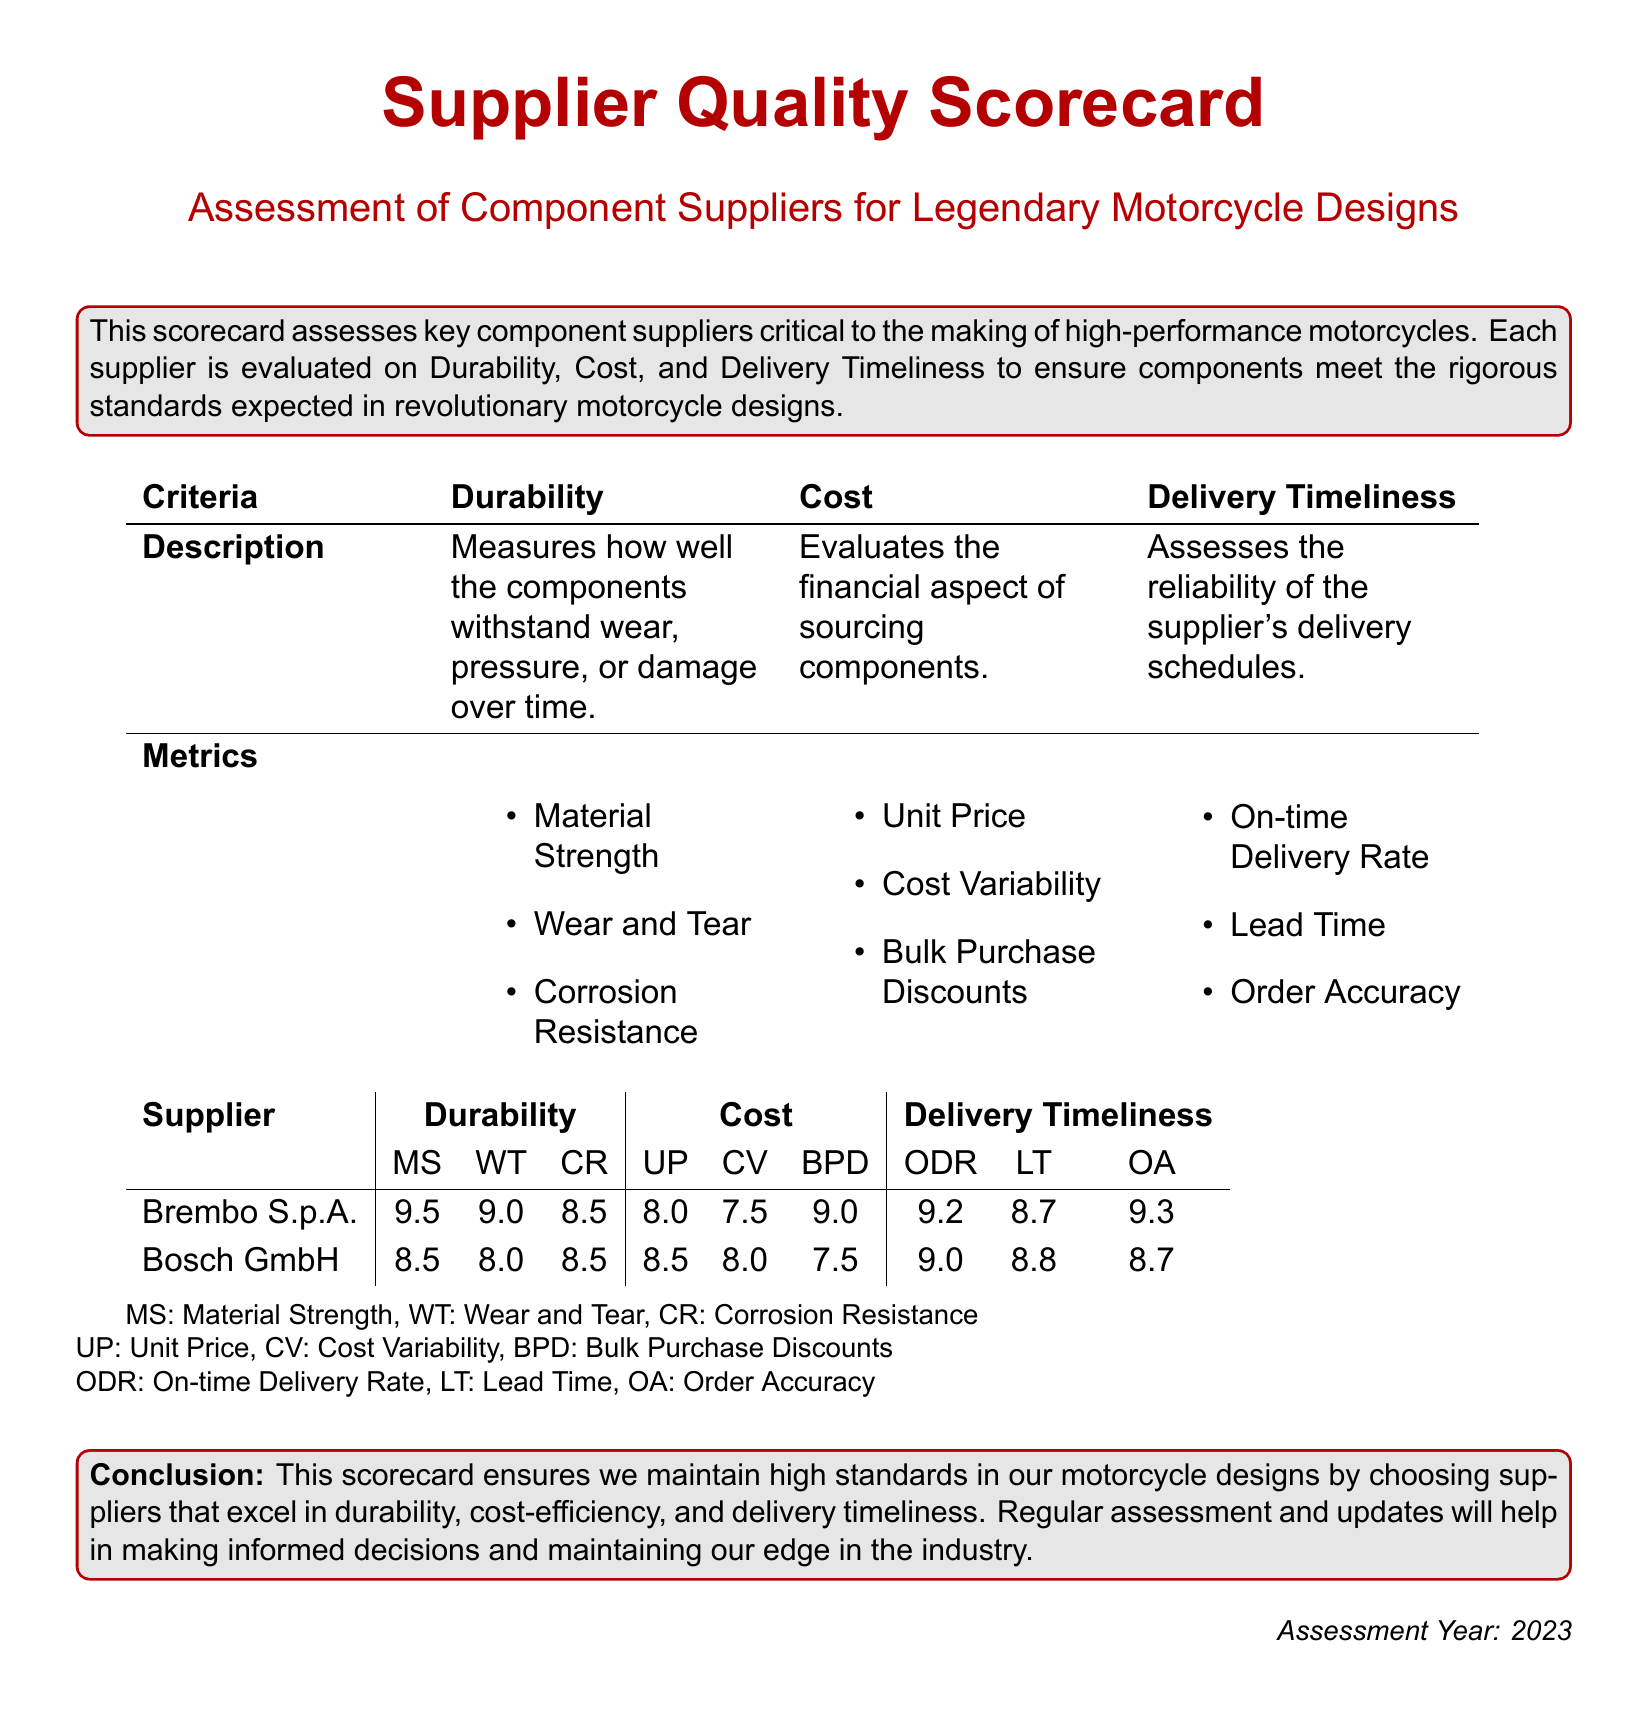What is the title of the scorecard? The title of the scorecard is presented prominently at the top of the document.
Answer: Supplier Quality Scorecard What is the assessment year stated in the document? The assessment year is mentioned at the bottom of the document.
Answer: 2023 Which supplier has the highest score in Material Strength? The scores for Material Strength are listed in a table for each supplier.
Answer: Brembo S.p.A What is the metric used to evaluate Delivery Timeliness? The metrics for Delivery Timeliness are specified in the criteria section of the document.
Answer: On-time Delivery Rate How many metrics are used to assess Durability? The metrics for Durability are detailed in a bullet-point format in the document.
Answer: Three Which supplier has the lowest Cost score for Unit Price? The scores are compared within the Cost section for each supplier.
Answer: Bosch GmbH What is the description of the Cost criterion? The description is provided in a tabular format under the Cost heading.
Answer: Evaluates the financial aspect of sourcing components Which metric shows the likelihood of suppliers delivering on time? This metric is specifically highlighted under the Delivery Timeliness section.
Answer: On-time Delivery Rate 